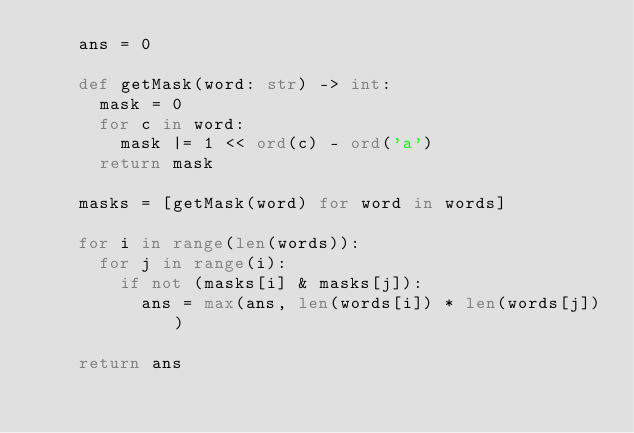Convert code to text. <code><loc_0><loc_0><loc_500><loc_500><_Python_>    ans = 0

    def getMask(word: str) -> int:
      mask = 0
      for c in word:
        mask |= 1 << ord(c) - ord('a')
      return mask

    masks = [getMask(word) for word in words]

    for i in range(len(words)):
      for j in range(i):
        if not (masks[i] & masks[j]):
          ans = max(ans, len(words[i]) * len(words[j]))

    return ans
</code> 